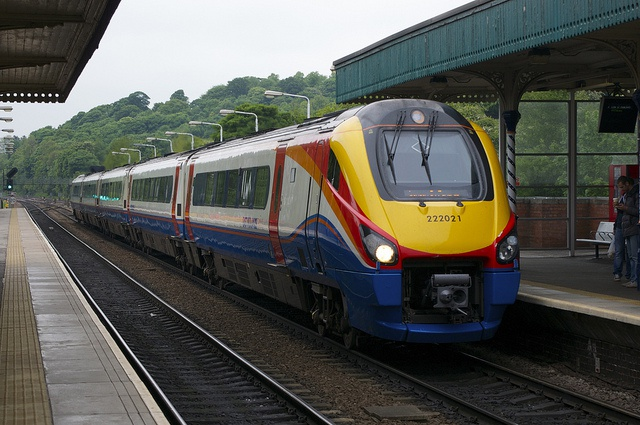Describe the objects in this image and their specific colors. I can see train in black, gray, darkgray, and navy tones, people in black and gray tones, bench in black, darkgray, and gray tones, and traffic light in black, teal, white, and lightblue tones in this image. 